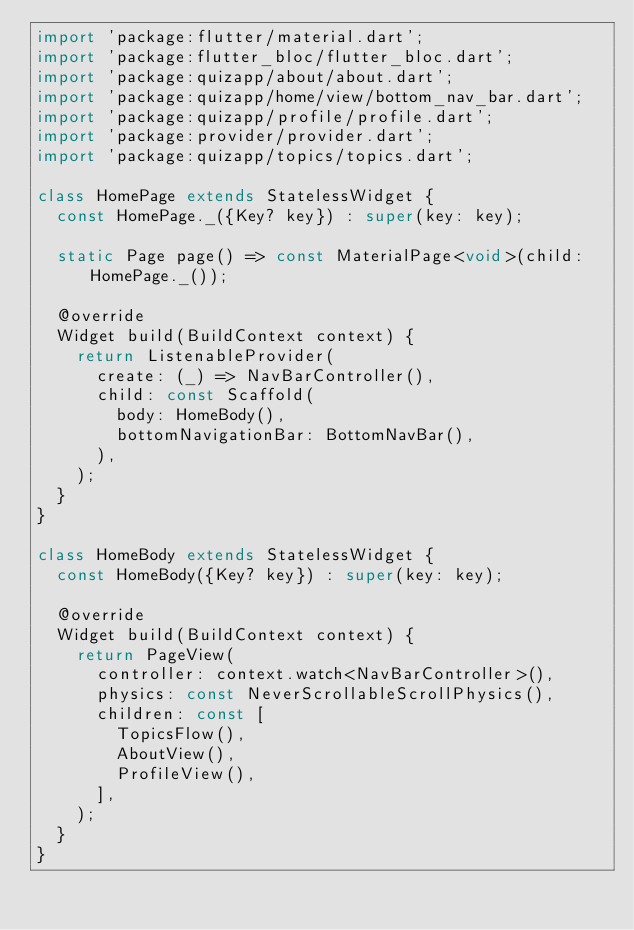Convert code to text. <code><loc_0><loc_0><loc_500><loc_500><_Dart_>import 'package:flutter/material.dart';
import 'package:flutter_bloc/flutter_bloc.dart';
import 'package:quizapp/about/about.dart';
import 'package:quizapp/home/view/bottom_nav_bar.dart';
import 'package:quizapp/profile/profile.dart';
import 'package:provider/provider.dart';
import 'package:quizapp/topics/topics.dart';

class HomePage extends StatelessWidget {
  const HomePage._({Key? key}) : super(key: key);

  static Page page() => const MaterialPage<void>(child: HomePage._());

  @override
  Widget build(BuildContext context) {
    return ListenableProvider(
      create: (_) => NavBarController(),
      child: const Scaffold(
        body: HomeBody(),
        bottomNavigationBar: BottomNavBar(),
      ),
    );
  }
}

class HomeBody extends StatelessWidget {
  const HomeBody({Key? key}) : super(key: key);

  @override
  Widget build(BuildContext context) {
    return PageView(
      controller: context.watch<NavBarController>(),
      physics: const NeverScrollableScrollPhysics(),
      children: const [
        TopicsFlow(),
        AboutView(),
        ProfileView(),
      ],
    );
  }
}
</code> 